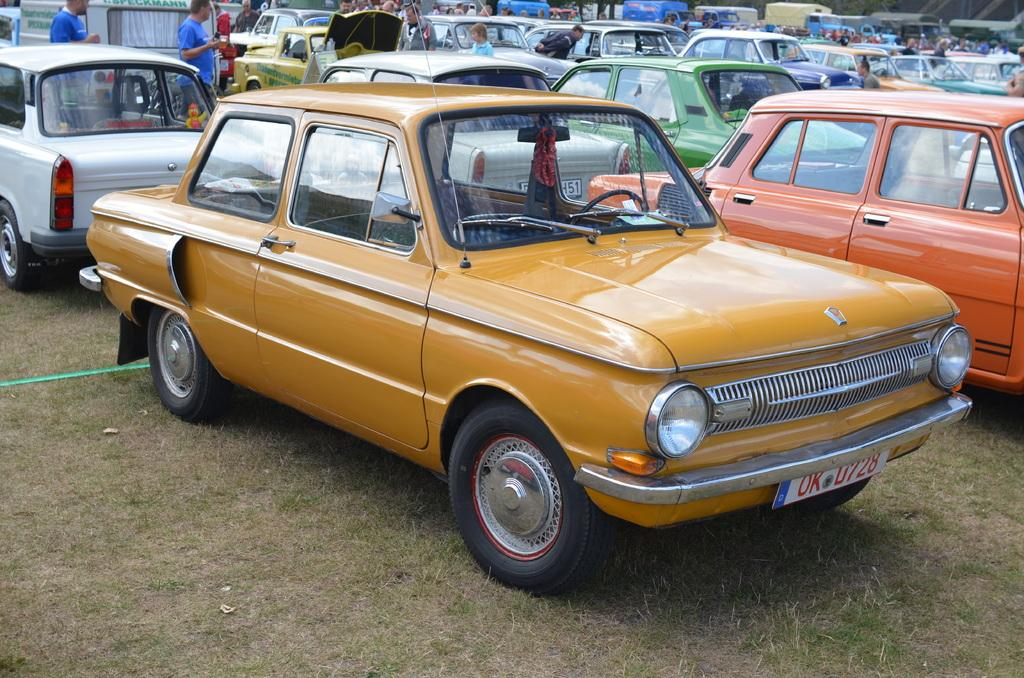What is located on the ground in the image? There is a group of cars on the ground. What type of vegetation can be seen in the image? There is grass visible in the image. What are the people in the image doing? There is a group of people standing. What else can be seen in the background of the image? There are vehicles visible in the background. What type of government is depicted in the image? There is no depiction of a government in the image; it features a group of cars, grass, a group of people standing, and vehicles in the background. Can you tell me how many owls are present in the image? There are no owls present in the image. 